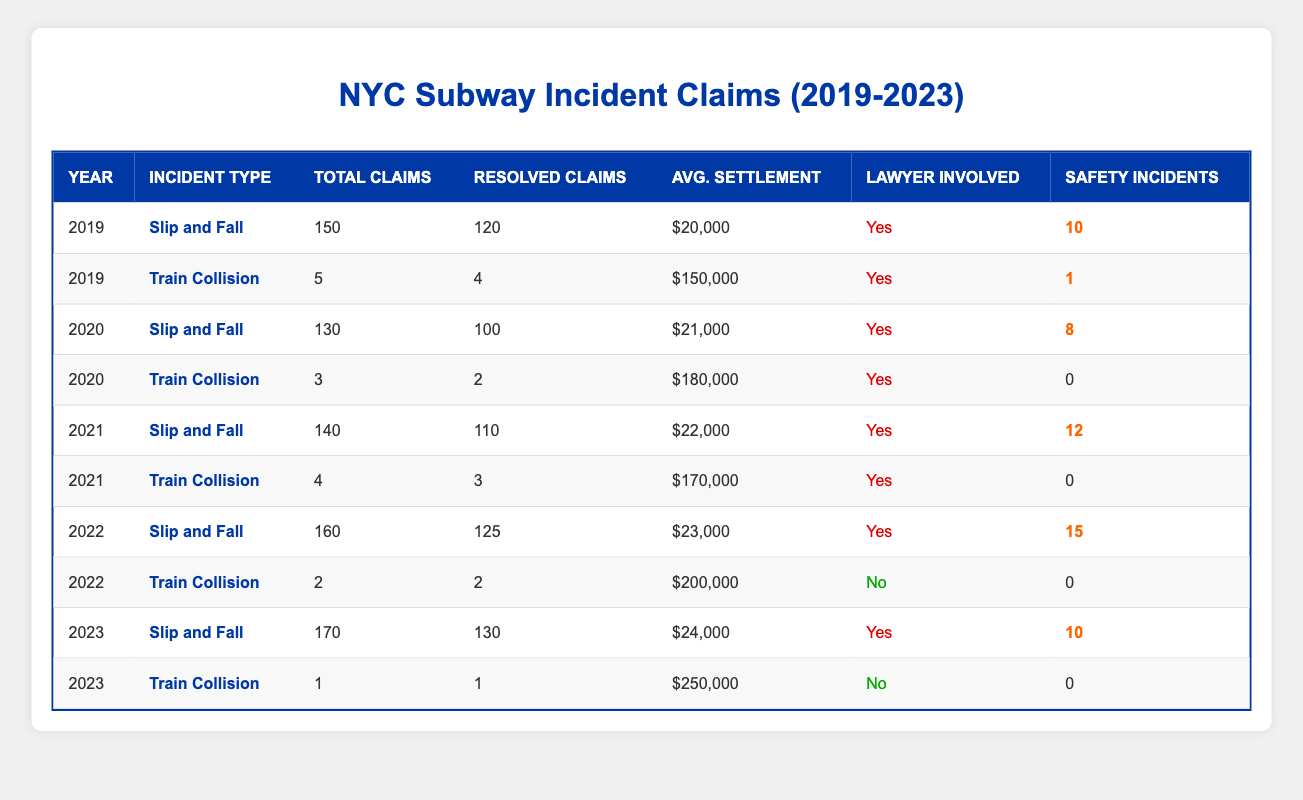What was the total number of personal injury claims for Slip and Fall incidents in 2022? According to the table, in 2022, the total number of claims specifically for Slip and Fall incidents is provided as 160.
Answer: 160 How many Train Collision claims were filed in 2021? In the table, for the year 2021, the total number of Train Collision claims is listed as 4.
Answer: 4 What was the average settlement amount for Slip and Fall claims in 2023? For 2023, the average settlement amount for Slip and Fall claims is indicated in the table as $24,000.
Answer: $24,000 Did any Train Collision incidents in 2022 involve a lawyer? The table shows that for Train Collision incidents in 2022, there was no lawyer involvement indicated, which is classified as "No".
Answer: No What was the difference in the total number of claims for Slip and Fall incidents between 2019 and 2023? In 2019, there were 150 claims and in 2023, there were 170 claims. The difference is 170 - 150 = 20 claims.
Answer: 20 What percentage of Train Collision claims were resolved in 2020? There were 3 claims for Train Collision in 2020, out of which 2 were resolved. To find the percentage resolved: (2 resolved / 3 total claims) * 100 = 66.67%.
Answer: 66.67% What was the total number of resolved claims for both incident types in 2021? In 2021, there were 110 resolved claims for Slip and Fall and 3 for Train Collision, totaling 110 + 3 = 113 resolved claims.
Answer: 113 How many total safety incidents were reported for Slip and Fall claims from 2019 to 2023? Adding the reported safety incidents for Slip and Falls across the years: 10 (2019) + 8 (2020) + 12 (2021) + 15 (2022) + 10 (2023) gives a total of 55 safety incidents.
Answer: 55 What is the trend in average settlement amounts for Slip and Fall claims from 2019 to 2023? The average settlements for Slip and Fall are: 2019: $20,000, 2020: $21,000, 2021: $22,000, 2022: $23,000, and 2023: $24,000, showing a consistent increase of $1,000 each year.
Answer: Increasing How many more claims for Slip and Fall incidents were resolved than those for Train Collision in 2022? In 2022, 125 Slip and Fall claims were resolved while only 2 Train Collision claims were resolved, which gives a difference of 125 - 2 = 123 claims resolved for Slip and Fall over Train Collision.
Answer: 123 